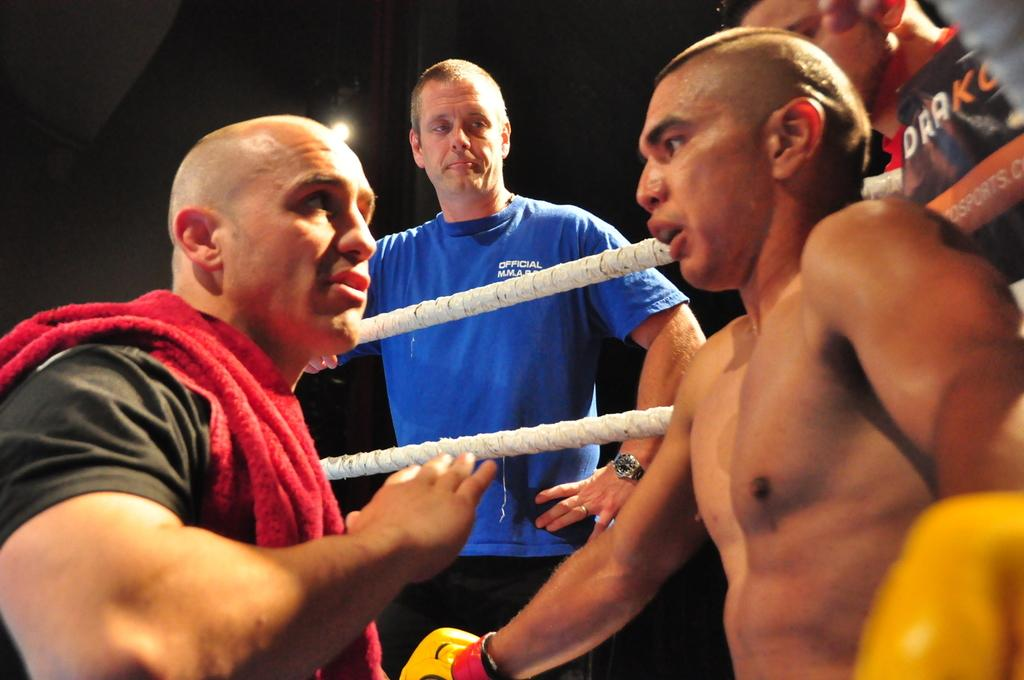How many people are in the image? There are four persons in the image. What objects can be seen in the image besides the people? There are two ropes in the image. What is the color of the background in the image? The background of the image is dark. Can you tell me how many goldfish are swimming in the image? There are no goldfish present in the image. What type of chalk is being used by the persons in the image? There is no chalk visible in the image. 